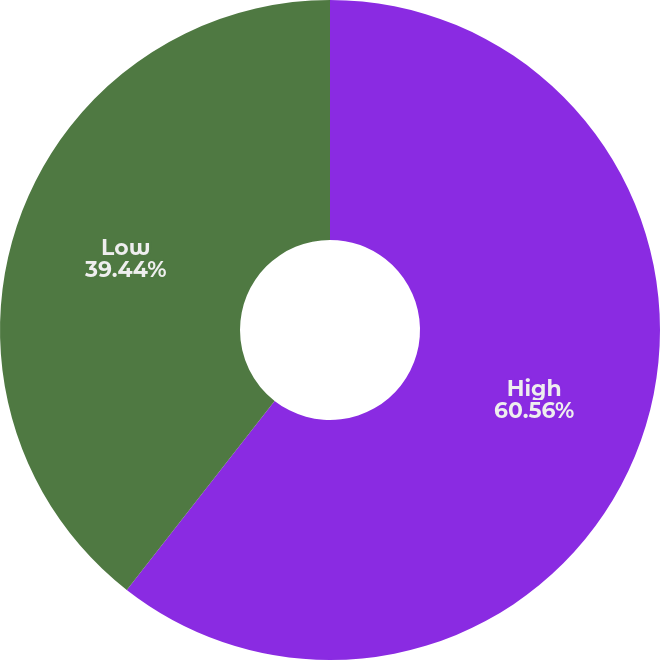Convert chart to OTSL. <chart><loc_0><loc_0><loc_500><loc_500><pie_chart><fcel>High<fcel>Low<nl><fcel>60.56%<fcel>39.44%<nl></chart> 